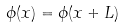Convert formula to latex. <formula><loc_0><loc_0><loc_500><loc_500>\phi ( x ) = \phi ( x + L )</formula> 